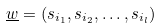<formula> <loc_0><loc_0><loc_500><loc_500>\underline { w } = ( s _ { i _ { 1 } } , s _ { i _ { 2 } } , \dots , s _ { i _ { l } } )</formula> 